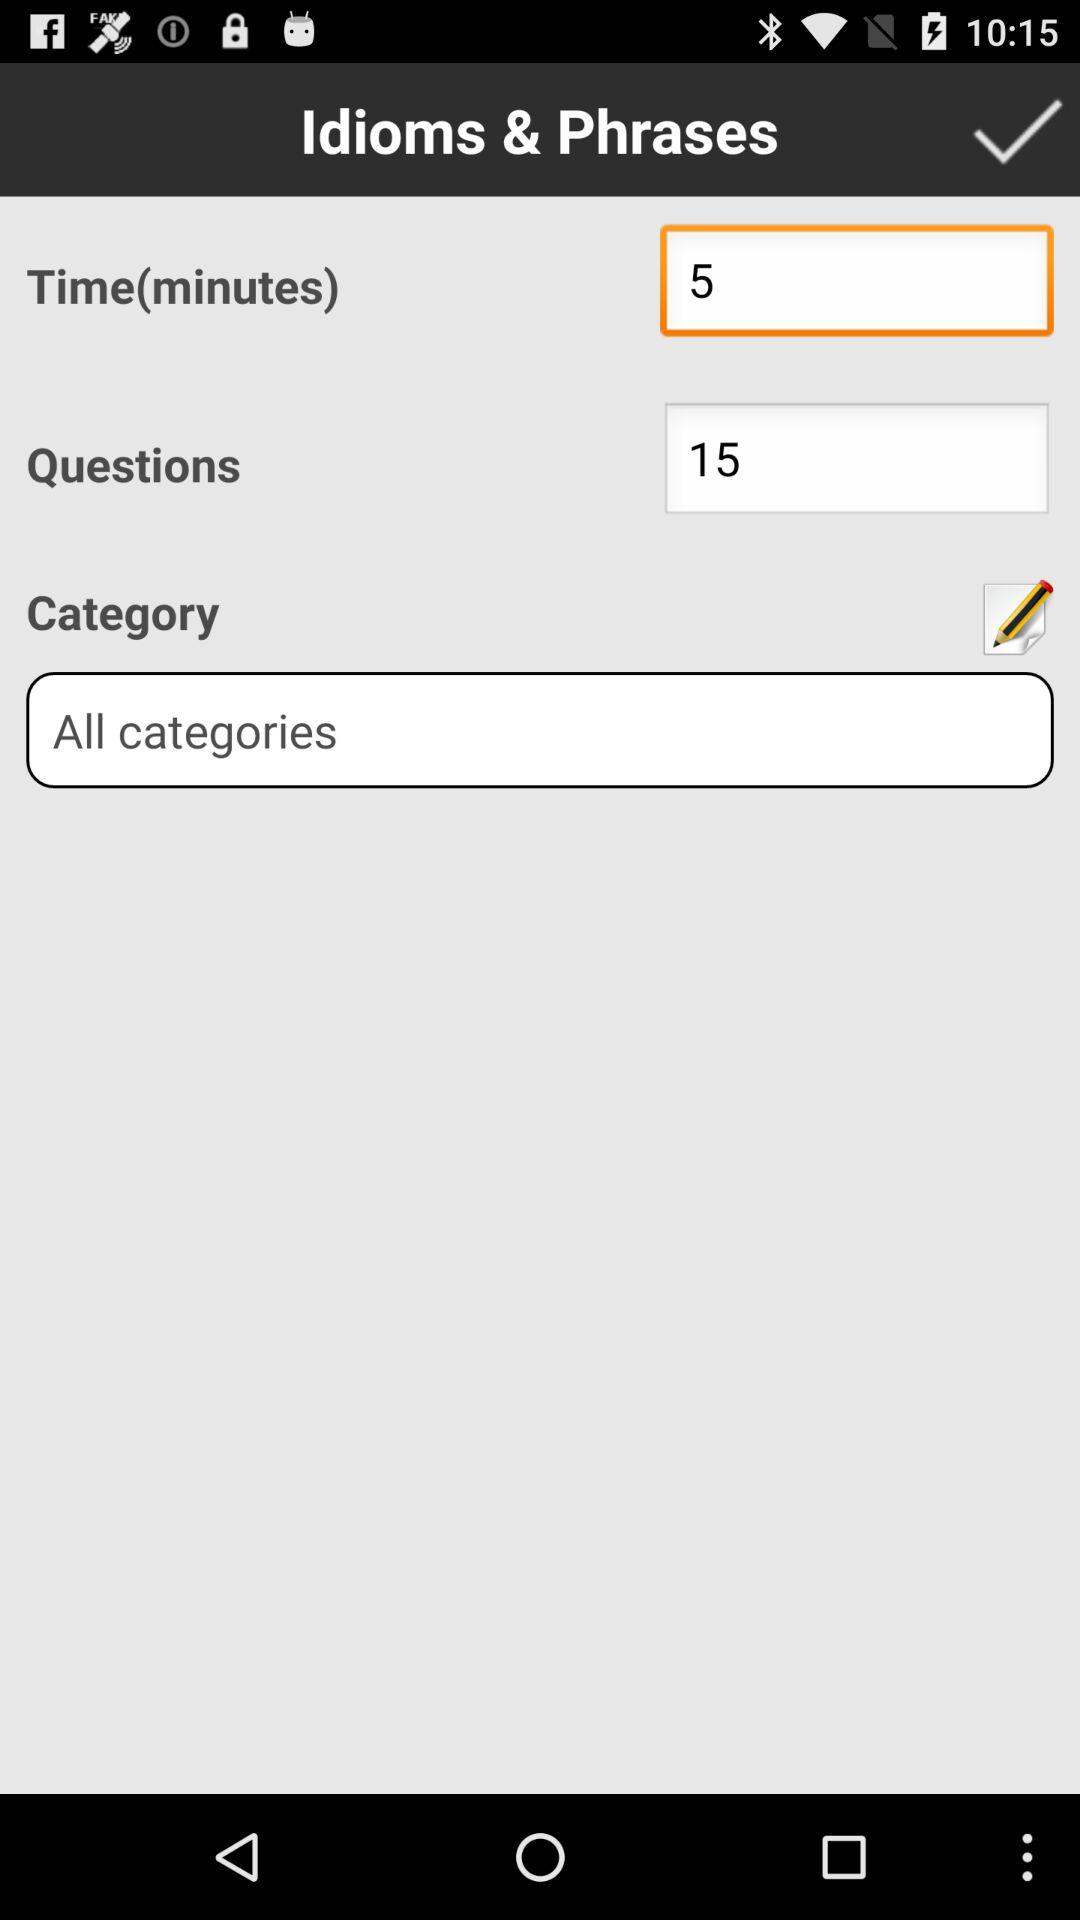What is the first question?
When the provided information is insufficient, respond with <no answer>. <no answer> 